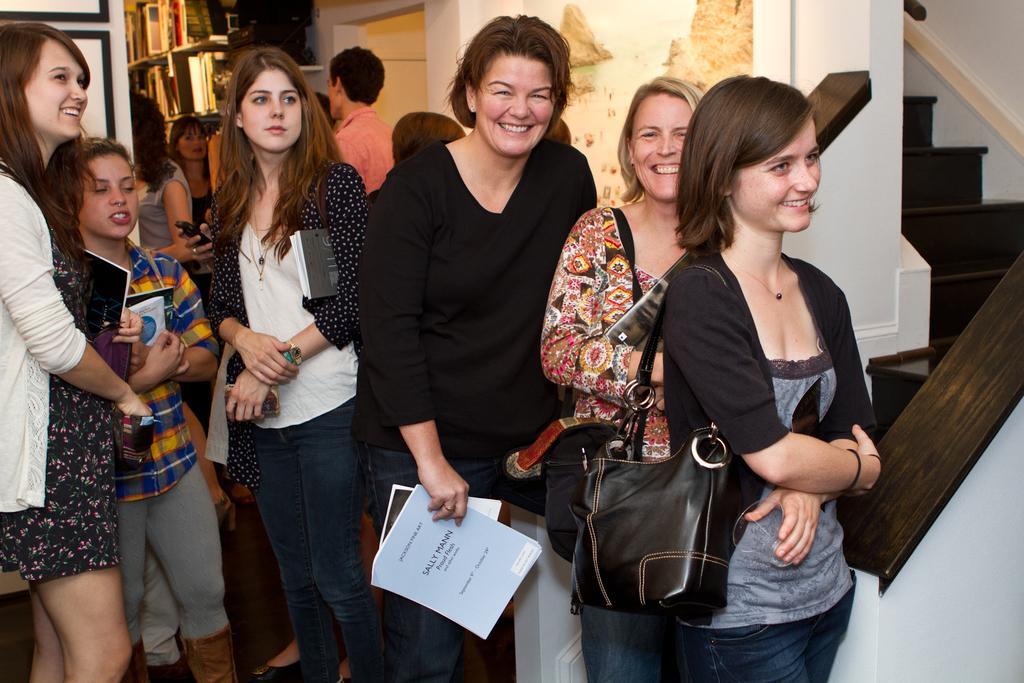In one or two sentences, can you explain what this image depicts? People are standing holding bag and paper,here there is shelf with books. 